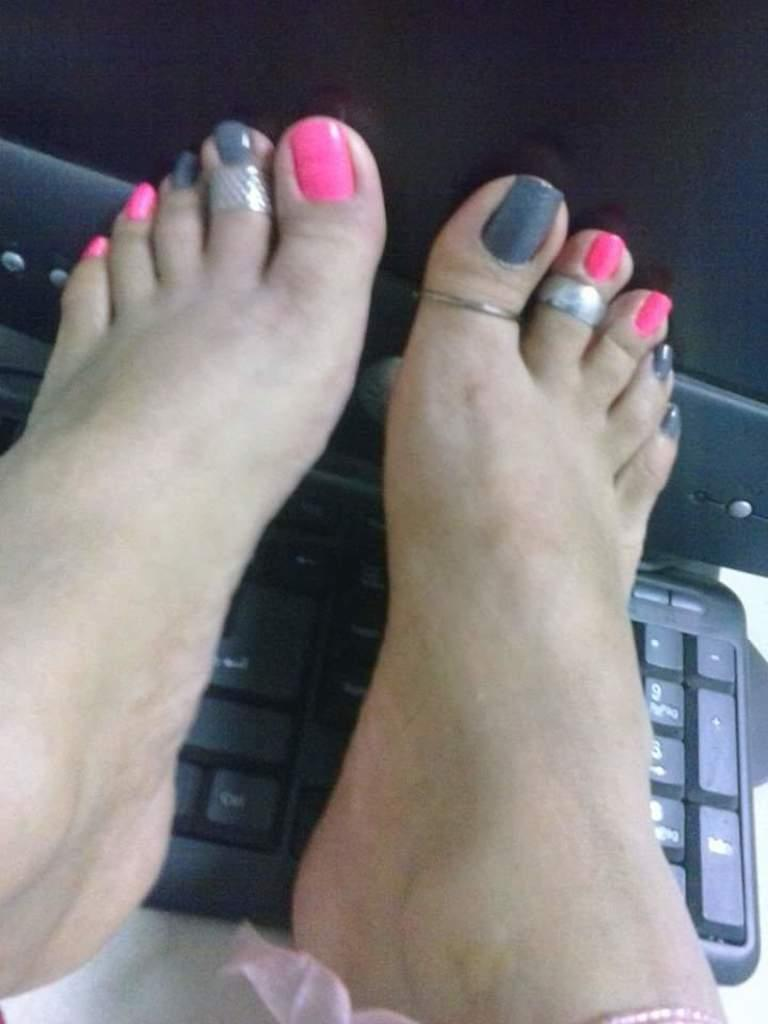What body part is visible in the image? There are women's feet in the image. What objects are the feet on? The feet are on a keyboard and a monitor. How does the earthquake affect the women's feet in the image? There is no earthquake present in the image, so its effects cannot be observed. 